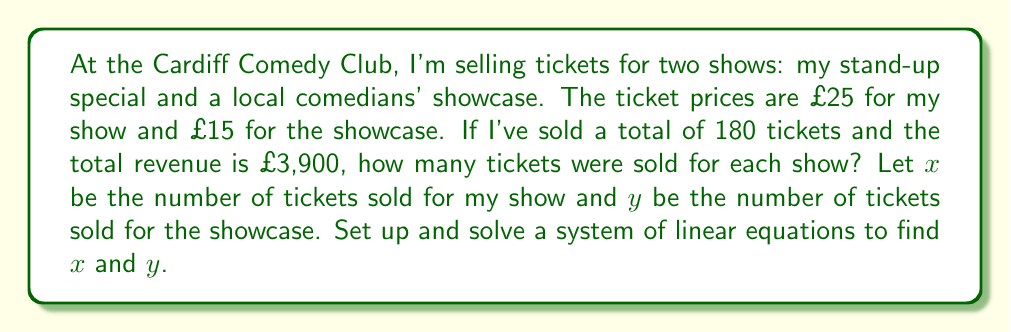Provide a solution to this math problem. Let's approach this step-by-step:

1) First, we need to set up our system of linear equations based on the given information:

   Equation 1 (total tickets): $x + y = 180$
   Equation 2 (total revenue): $25x + 15y = 3900$

2) We can solve this system using substitution. Let's rearrange Equation 1 to isolate $y$:

   $y = 180 - x$

3) Now, let's substitute this expression for $y$ into Equation 2:

   $25x + 15(180 - x) = 3900$

4) Let's expand the brackets:

   $25x + 2700 - 15x = 3900$

5) Simplify:

   $10x + 2700 = 3900$

6) Subtract 2700 from both sides:

   $10x = 1200$

7) Divide both sides by 10:

   $x = 120$

8) Now that we know $x$, we can find $y$ using Equation 1:

   $y = 180 - 120 = 60$

Therefore, 120 tickets were sold for my stand-up special, and 60 tickets were sold for the local comedians' showcase.
Answer: $x = 120, y = 60$ 